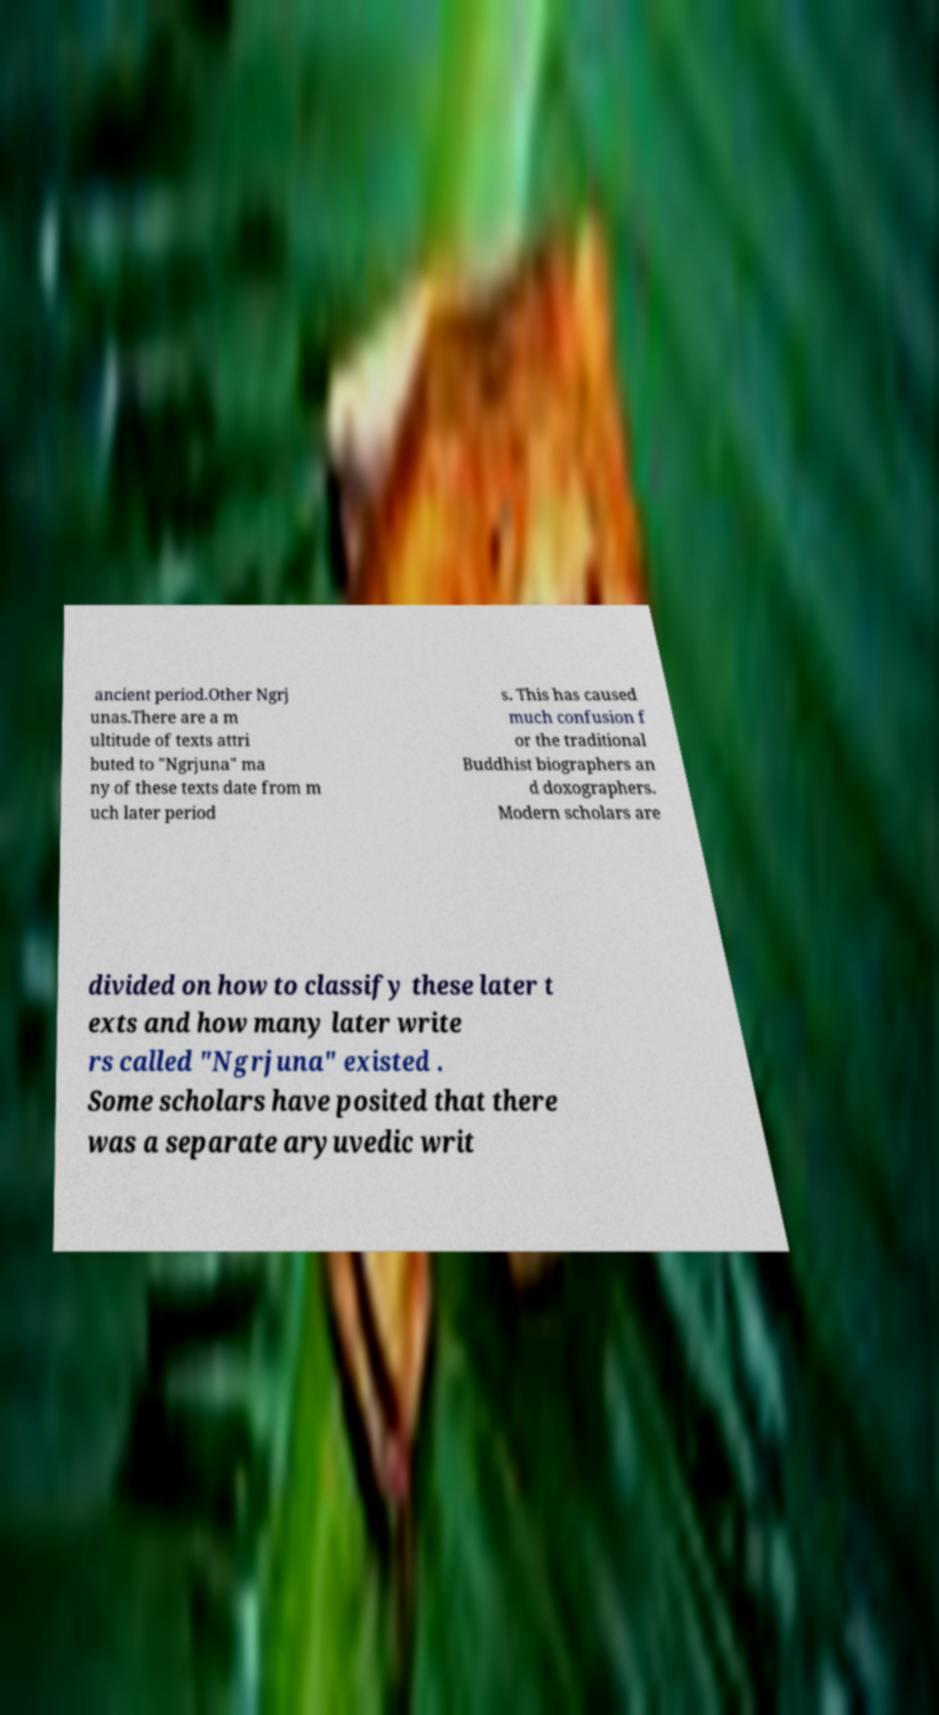Could you extract and type out the text from this image? ancient period.Other Ngrj unas.There are a m ultitude of texts attri buted to "Ngrjuna" ma ny of these texts date from m uch later period s. This has caused much confusion f or the traditional Buddhist biographers an d doxographers. Modern scholars are divided on how to classify these later t exts and how many later write rs called "Ngrjuna" existed . Some scholars have posited that there was a separate aryuvedic writ 